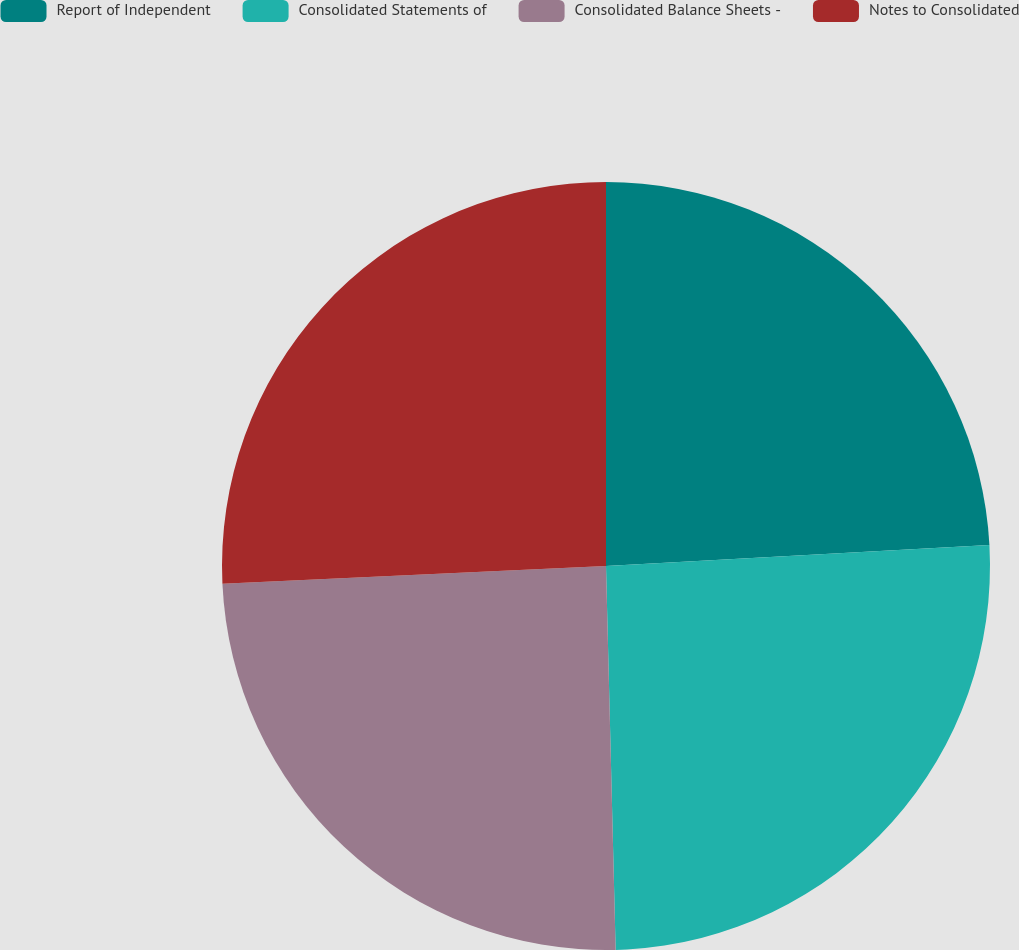Convert chart. <chart><loc_0><loc_0><loc_500><loc_500><pie_chart><fcel>Report of Independent<fcel>Consolidated Statements of<fcel>Consolidated Balance Sheets -<fcel>Notes to Consolidated<nl><fcel>24.13%<fcel>25.47%<fcel>24.66%<fcel>25.74%<nl></chart> 